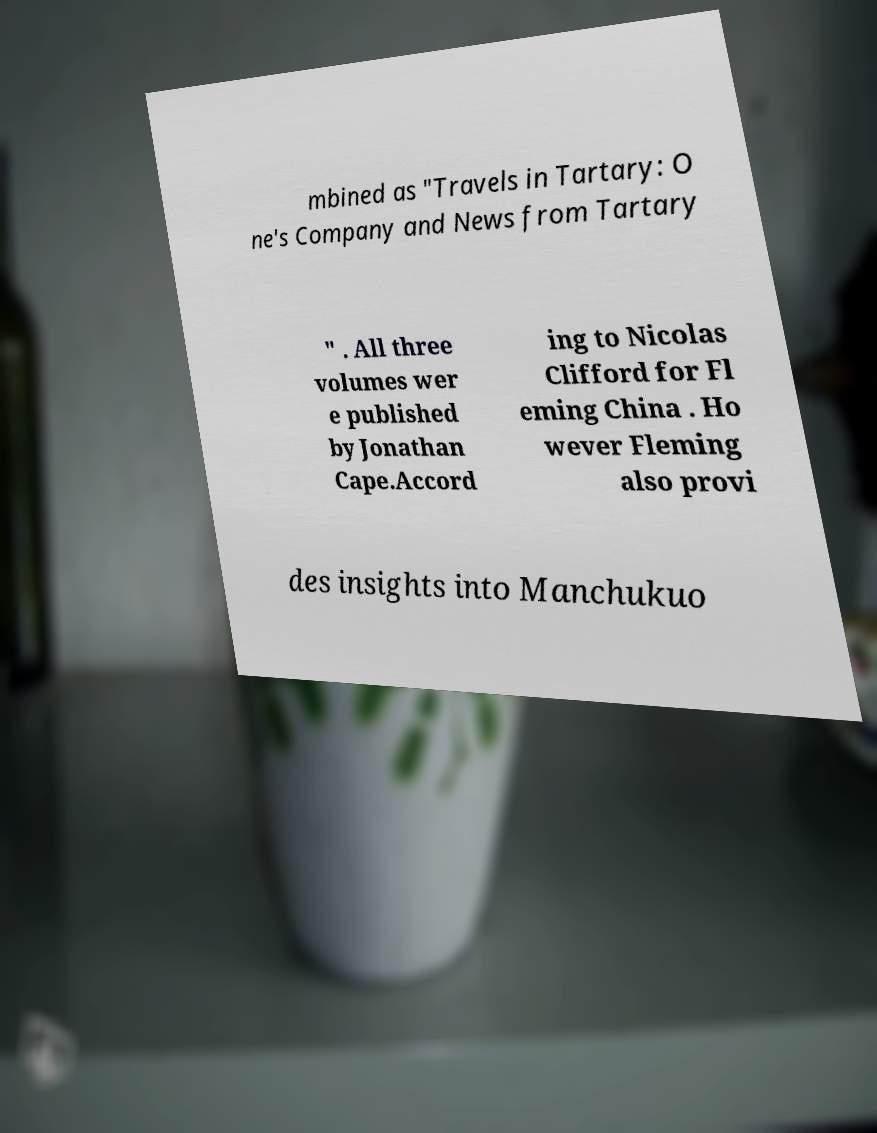What messages or text are displayed in this image? I need them in a readable, typed format. mbined as "Travels in Tartary: O ne's Company and News from Tartary " . All three volumes wer e published by Jonathan Cape.Accord ing to Nicolas Clifford for Fl eming China . Ho wever Fleming also provi des insights into Manchukuo 